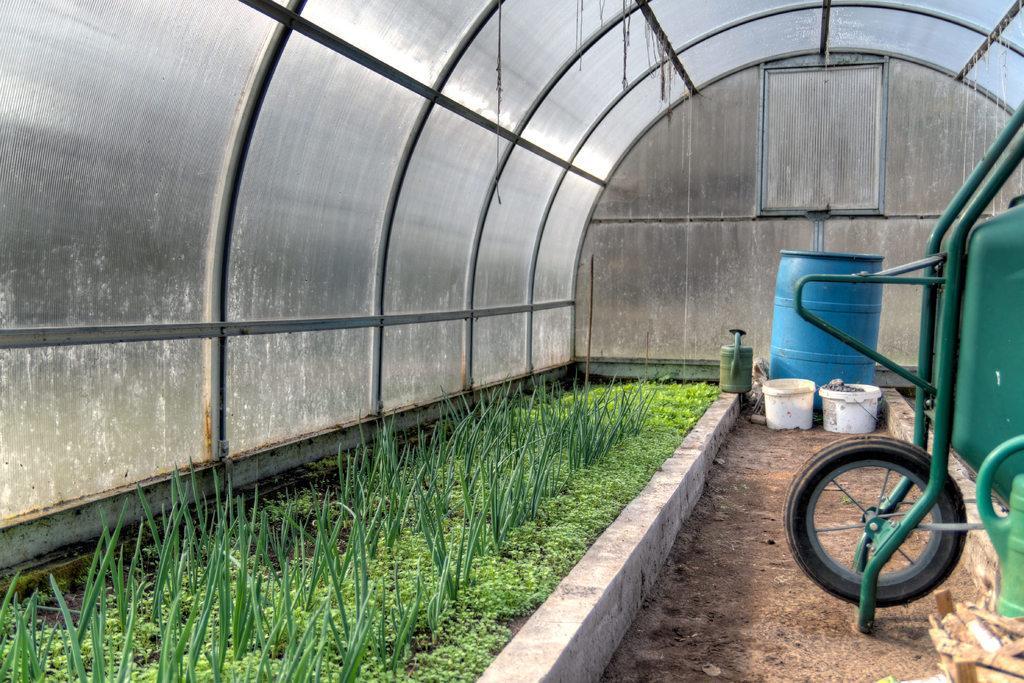Please provide a concise description of this image. This picture is clicked outside under an arch. On the left we can see the green grass. On the right there is a vehicle placed on the ground. In the center there are some objects placed on the ground. 